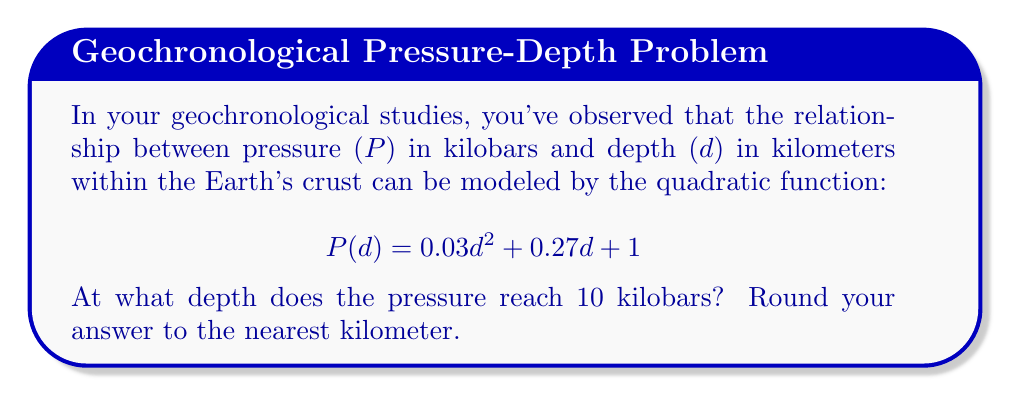Teach me how to tackle this problem. To solve this problem, we need to find the value of d when P(d) = 10. Let's approach this step-by-step:

1) We start with the equation:
   $$0.03d^2 + 0.27d + 1 = 10$$

2) Subtract 10 from both sides to get the equation in standard form:
   $$0.03d^2 + 0.27d - 9 = 0$$

3) This is a quadratic equation. We can solve it using the quadratic formula:
   $$d = \frac{-b \pm \sqrt{b^2 - 4ac}}{2a}$$
   where $a = 0.03$, $b = 0.27$, and $c = -9$

4) Substituting these values:
   $$d = \frac{-0.27 \pm \sqrt{0.27^2 - 4(0.03)(-9)}}{2(0.03)}$$

5) Simplify under the square root:
   $$d = \frac{-0.27 \pm \sqrt{0.0729 + 1.08}}{0.06}$$
   $$d = \frac{-0.27 \pm \sqrt{1.1529}}{0.06}$$
   $$d = \frac{-0.27 \pm 1.0737}{0.06}$$

6) This gives us two solutions:
   $$d = \frac{-0.27 + 1.0737}{0.06} \approx 13.395$$
   $$d = \frac{-0.27 - 1.0737}{0.06} \approx -22.395$$

7) Since depth cannot be negative in this context, we discard the negative solution.

8) Rounding to the nearest kilometer:
   13.395 ≈ 13 km
Answer: 13 km 